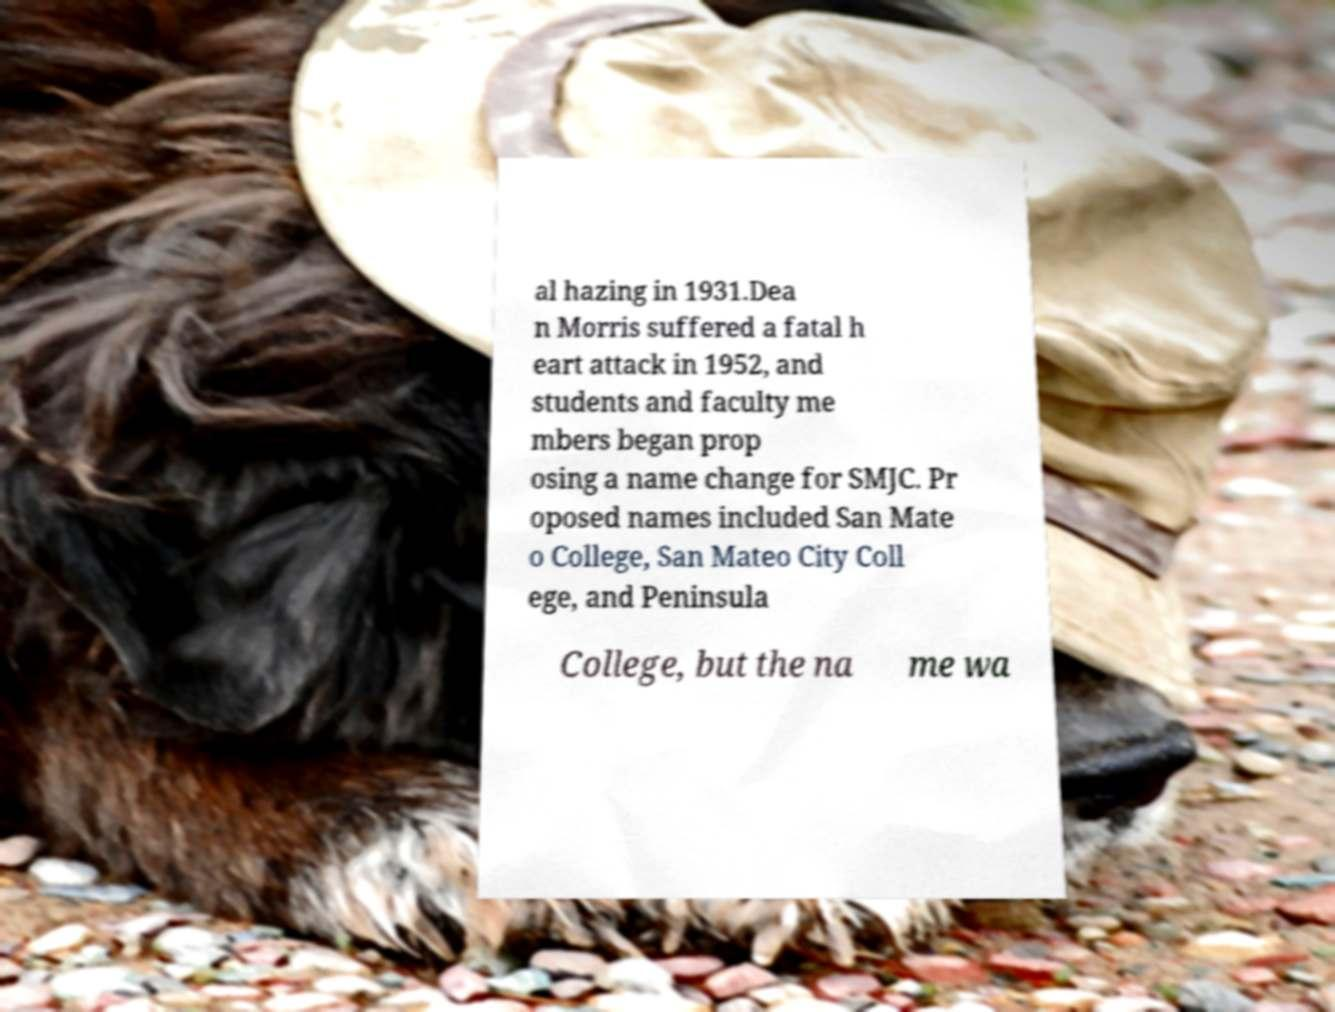Please identify and transcribe the text found in this image. al hazing in 1931.Dea n Morris suffered a fatal h eart attack in 1952, and students and faculty me mbers began prop osing a name change for SMJC. Pr oposed names included San Mate o College, San Mateo City Coll ege, and Peninsula College, but the na me wa 